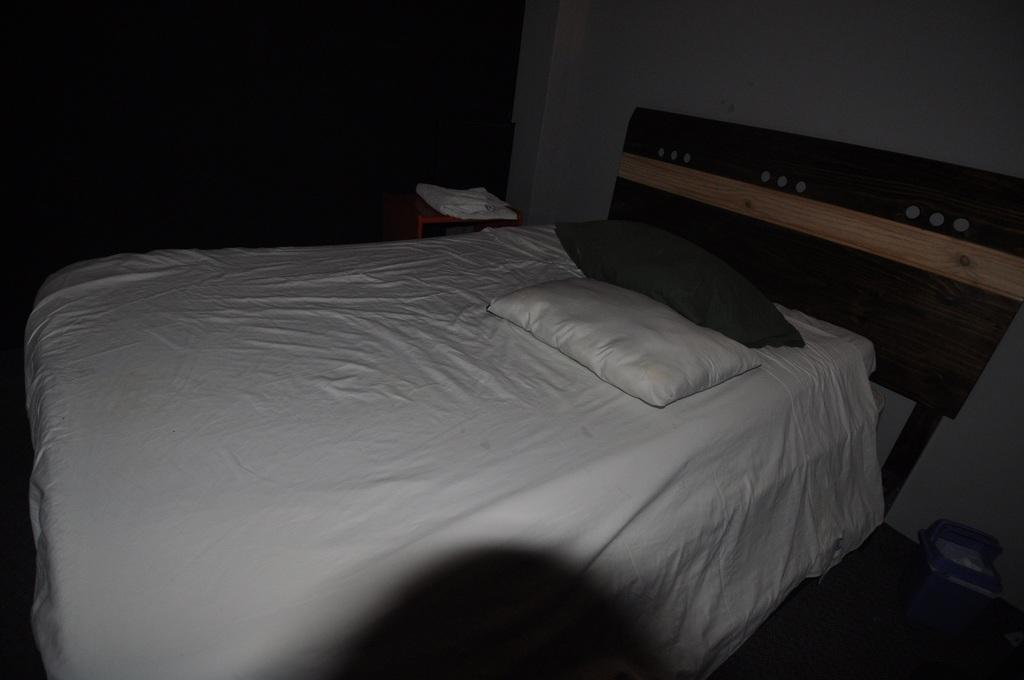What piece of furniture is present in the image? There is a bed in the image. What is placed on the bed? There are pillows on the bed. What type of silk fabric is draped over the horses in the image? There are no horses or silk fabric present in the image; it only features a bed with pillows. What kind of music can be heard playing in the background of the image? There is no music present in the image; it only features a bed with pillows. 